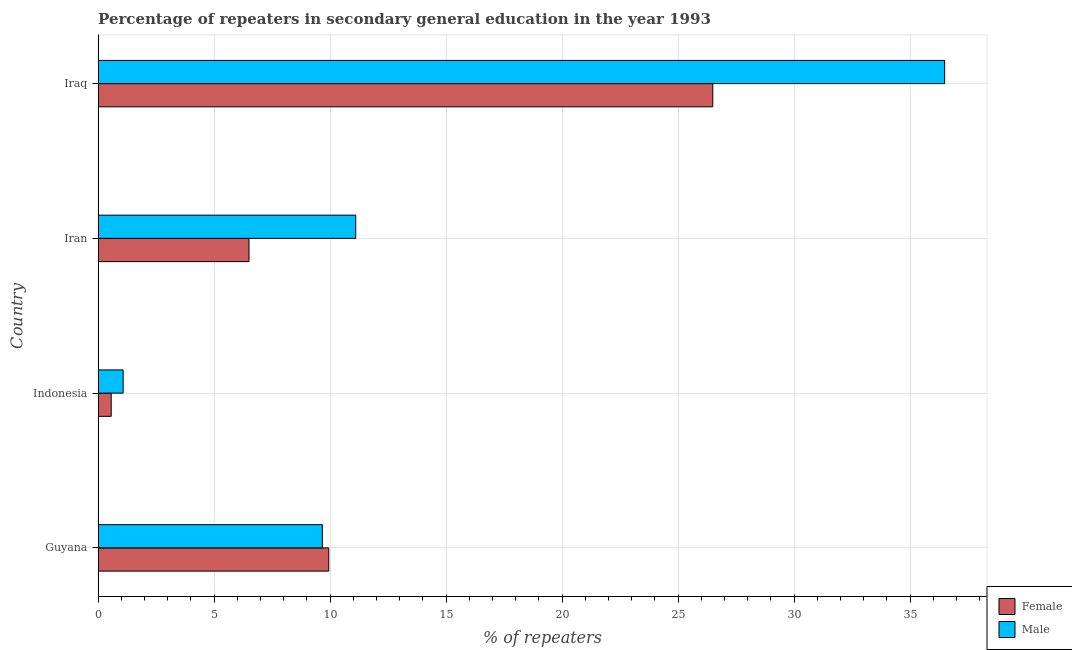Are the number of bars per tick equal to the number of legend labels?
Provide a succinct answer. Yes. How many bars are there on the 3rd tick from the top?
Offer a terse response. 2. How many bars are there on the 1st tick from the bottom?
Ensure brevity in your answer.  2. What is the percentage of female repeaters in Iraq?
Provide a succinct answer. 26.5. Across all countries, what is the maximum percentage of male repeaters?
Give a very brief answer. 36.49. Across all countries, what is the minimum percentage of female repeaters?
Keep it short and to the point. 0.56. In which country was the percentage of male repeaters maximum?
Your answer should be compact. Iraq. What is the total percentage of male repeaters in the graph?
Offer a very short reply. 58.34. What is the difference between the percentage of male repeaters in Indonesia and that in Iran?
Your answer should be very brief. -10.03. What is the difference between the percentage of female repeaters in Indonesia and the percentage of male repeaters in Iraq?
Your answer should be very brief. -35.93. What is the average percentage of male repeaters per country?
Your answer should be compact. 14.59. What is the difference between the percentage of male repeaters and percentage of female repeaters in Indonesia?
Offer a very short reply. 0.52. What is the ratio of the percentage of male repeaters in Guyana to that in Iran?
Offer a terse response. 0.87. What is the difference between the highest and the second highest percentage of female repeaters?
Offer a terse response. 16.55. What is the difference between the highest and the lowest percentage of male repeaters?
Offer a very short reply. 35.41. In how many countries, is the percentage of male repeaters greater than the average percentage of male repeaters taken over all countries?
Give a very brief answer. 1. Is the sum of the percentage of female repeaters in Indonesia and Iraq greater than the maximum percentage of male repeaters across all countries?
Ensure brevity in your answer.  No. What does the 1st bar from the bottom in Iran represents?
Your response must be concise. Female. How many bars are there?
Offer a terse response. 8. What is the difference between two consecutive major ticks on the X-axis?
Offer a very short reply. 5. Are the values on the major ticks of X-axis written in scientific E-notation?
Make the answer very short. No. Does the graph contain grids?
Offer a terse response. Yes. What is the title of the graph?
Make the answer very short. Percentage of repeaters in secondary general education in the year 1993. Does "Long-term debt" appear as one of the legend labels in the graph?
Provide a succinct answer. No. What is the label or title of the X-axis?
Your answer should be very brief. % of repeaters. What is the % of repeaters of Female in Guyana?
Provide a short and direct response. 9.94. What is the % of repeaters in Male in Guyana?
Your answer should be compact. 9.67. What is the % of repeaters in Female in Indonesia?
Keep it short and to the point. 0.56. What is the % of repeaters in Male in Indonesia?
Offer a terse response. 1.08. What is the % of repeaters of Female in Iran?
Your answer should be very brief. 6.5. What is the % of repeaters in Male in Iran?
Your response must be concise. 11.11. What is the % of repeaters of Female in Iraq?
Your answer should be very brief. 26.5. What is the % of repeaters of Male in Iraq?
Offer a terse response. 36.49. Across all countries, what is the maximum % of repeaters of Female?
Make the answer very short. 26.5. Across all countries, what is the maximum % of repeaters in Male?
Your response must be concise. 36.49. Across all countries, what is the minimum % of repeaters of Female?
Keep it short and to the point. 0.56. Across all countries, what is the minimum % of repeaters of Male?
Offer a very short reply. 1.08. What is the total % of repeaters of Female in the graph?
Give a very brief answer. 43.51. What is the total % of repeaters of Male in the graph?
Provide a short and direct response. 58.34. What is the difference between the % of repeaters of Female in Guyana and that in Indonesia?
Your answer should be very brief. 9.38. What is the difference between the % of repeaters in Male in Guyana and that in Indonesia?
Your answer should be very brief. 8.59. What is the difference between the % of repeaters of Female in Guyana and that in Iran?
Your answer should be very brief. 3.44. What is the difference between the % of repeaters in Male in Guyana and that in Iran?
Keep it short and to the point. -1.44. What is the difference between the % of repeaters in Female in Guyana and that in Iraq?
Offer a terse response. -16.55. What is the difference between the % of repeaters in Male in Guyana and that in Iraq?
Your answer should be very brief. -26.82. What is the difference between the % of repeaters of Female in Indonesia and that in Iran?
Give a very brief answer. -5.94. What is the difference between the % of repeaters in Male in Indonesia and that in Iran?
Offer a very short reply. -10.03. What is the difference between the % of repeaters in Female in Indonesia and that in Iraq?
Offer a terse response. -25.93. What is the difference between the % of repeaters of Male in Indonesia and that in Iraq?
Provide a short and direct response. -35.41. What is the difference between the % of repeaters of Female in Iran and that in Iraq?
Give a very brief answer. -19.99. What is the difference between the % of repeaters in Male in Iran and that in Iraq?
Provide a succinct answer. -25.39. What is the difference between the % of repeaters of Female in Guyana and the % of repeaters of Male in Indonesia?
Offer a very short reply. 8.86. What is the difference between the % of repeaters in Female in Guyana and the % of repeaters in Male in Iran?
Your answer should be compact. -1.16. What is the difference between the % of repeaters in Female in Guyana and the % of repeaters in Male in Iraq?
Your response must be concise. -26.55. What is the difference between the % of repeaters in Female in Indonesia and the % of repeaters in Male in Iran?
Your answer should be very brief. -10.54. What is the difference between the % of repeaters in Female in Indonesia and the % of repeaters in Male in Iraq?
Ensure brevity in your answer.  -35.93. What is the difference between the % of repeaters in Female in Iran and the % of repeaters in Male in Iraq?
Your response must be concise. -29.99. What is the average % of repeaters of Female per country?
Make the answer very short. 10.88. What is the average % of repeaters in Male per country?
Provide a succinct answer. 14.59. What is the difference between the % of repeaters of Female and % of repeaters of Male in Guyana?
Keep it short and to the point. 0.28. What is the difference between the % of repeaters of Female and % of repeaters of Male in Indonesia?
Offer a very short reply. -0.51. What is the difference between the % of repeaters in Female and % of repeaters in Male in Iran?
Your response must be concise. -4.6. What is the difference between the % of repeaters in Female and % of repeaters in Male in Iraq?
Your answer should be very brief. -10. What is the ratio of the % of repeaters in Female in Guyana to that in Indonesia?
Your answer should be very brief. 17.63. What is the ratio of the % of repeaters of Male in Guyana to that in Indonesia?
Offer a terse response. 8.96. What is the ratio of the % of repeaters of Female in Guyana to that in Iran?
Your answer should be compact. 1.53. What is the ratio of the % of repeaters of Male in Guyana to that in Iran?
Make the answer very short. 0.87. What is the ratio of the % of repeaters of Female in Guyana to that in Iraq?
Your answer should be very brief. 0.38. What is the ratio of the % of repeaters in Male in Guyana to that in Iraq?
Provide a succinct answer. 0.26. What is the ratio of the % of repeaters of Female in Indonesia to that in Iran?
Offer a terse response. 0.09. What is the ratio of the % of repeaters of Male in Indonesia to that in Iran?
Make the answer very short. 0.1. What is the ratio of the % of repeaters of Female in Indonesia to that in Iraq?
Your answer should be very brief. 0.02. What is the ratio of the % of repeaters of Male in Indonesia to that in Iraq?
Provide a short and direct response. 0.03. What is the ratio of the % of repeaters in Female in Iran to that in Iraq?
Your answer should be very brief. 0.25. What is the ratio of the % of repeaters of Male in Iran to that in Iraq?
Offer a terse response. 0.3. What is the difference between the highest and the second highest % of repeaters in Female?
Keep it short and to the point. 16.55. What is the difference between the highest and the second highest % of repeaters in Male?
Your answer should be very brief. 25.39. What is the difference between the highest and the lowest % of repeaters in Female?
Your response must be concise. 25.93. What is the difference between the highest and the lowest % of repeaters of Male?
Ensure brevity in your answer.  35.41. 